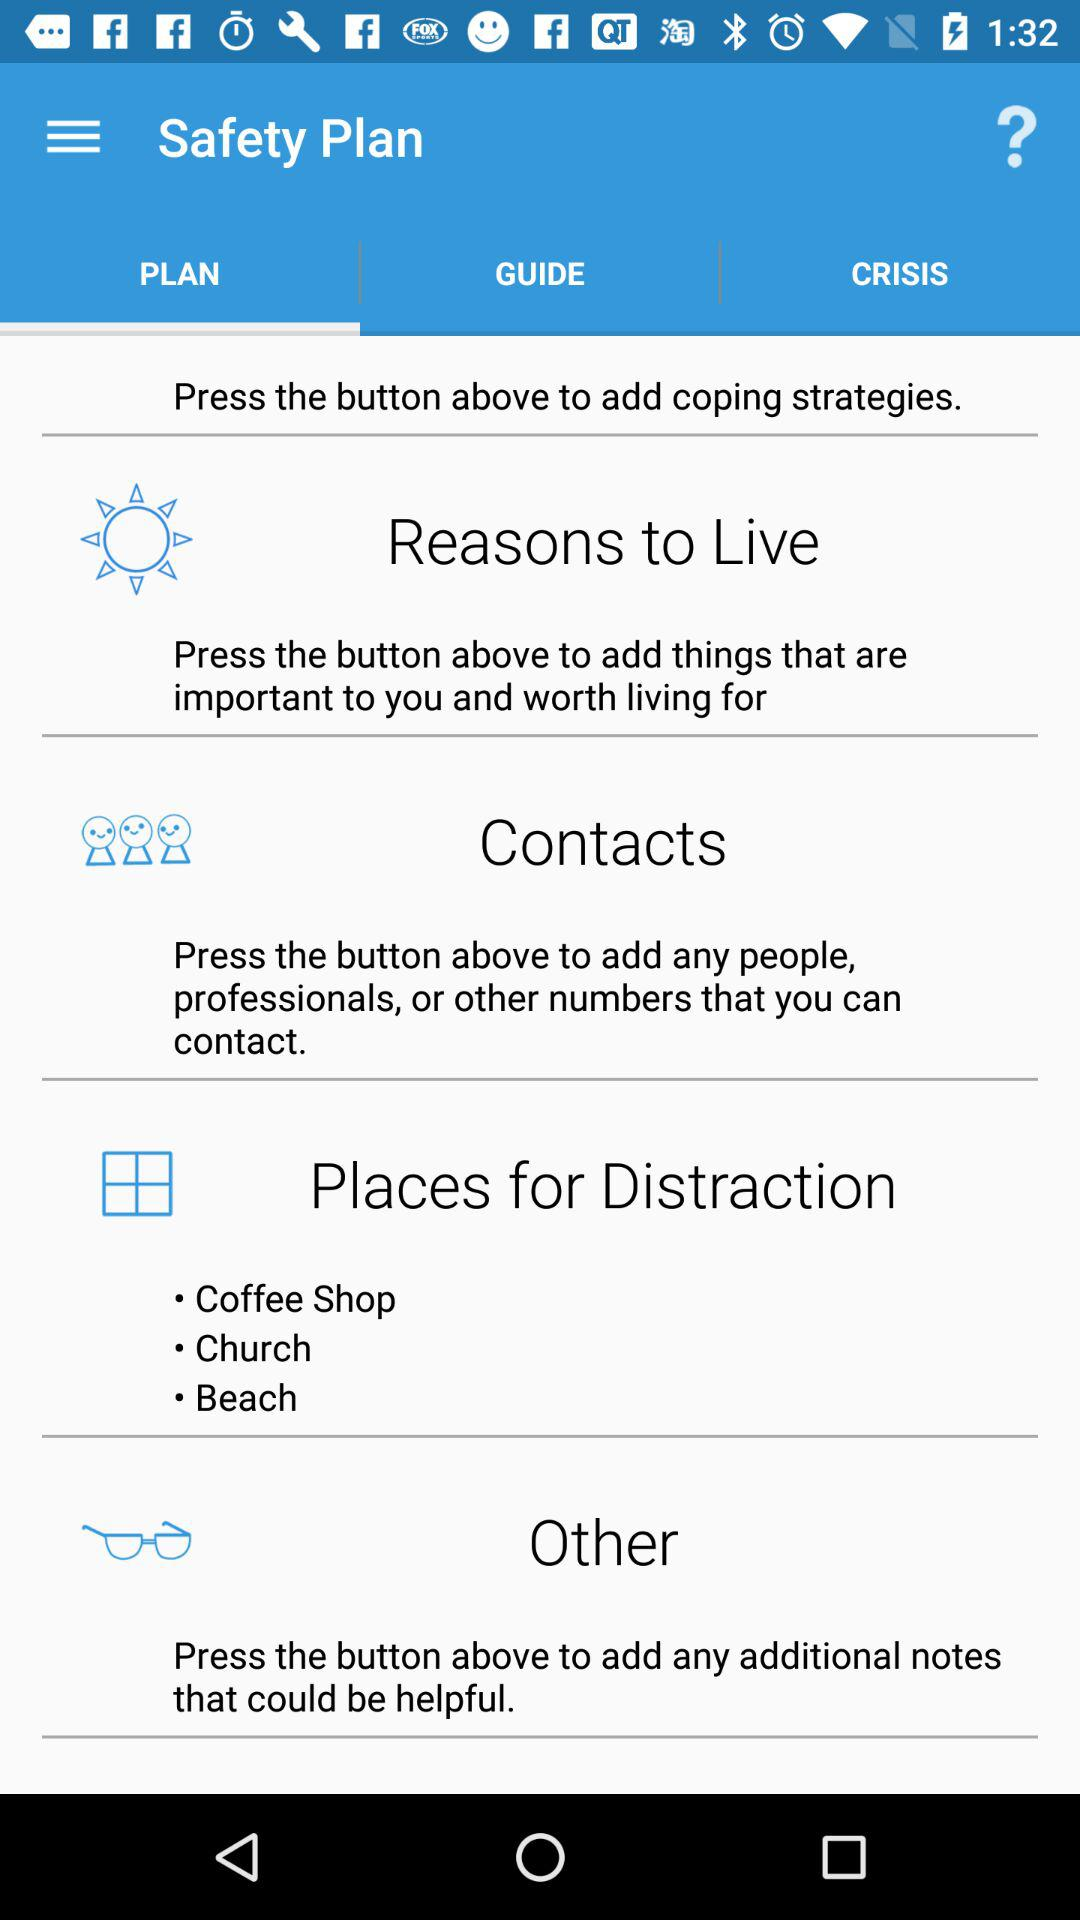Which tab is selected? The selected tab is "PLAN". 